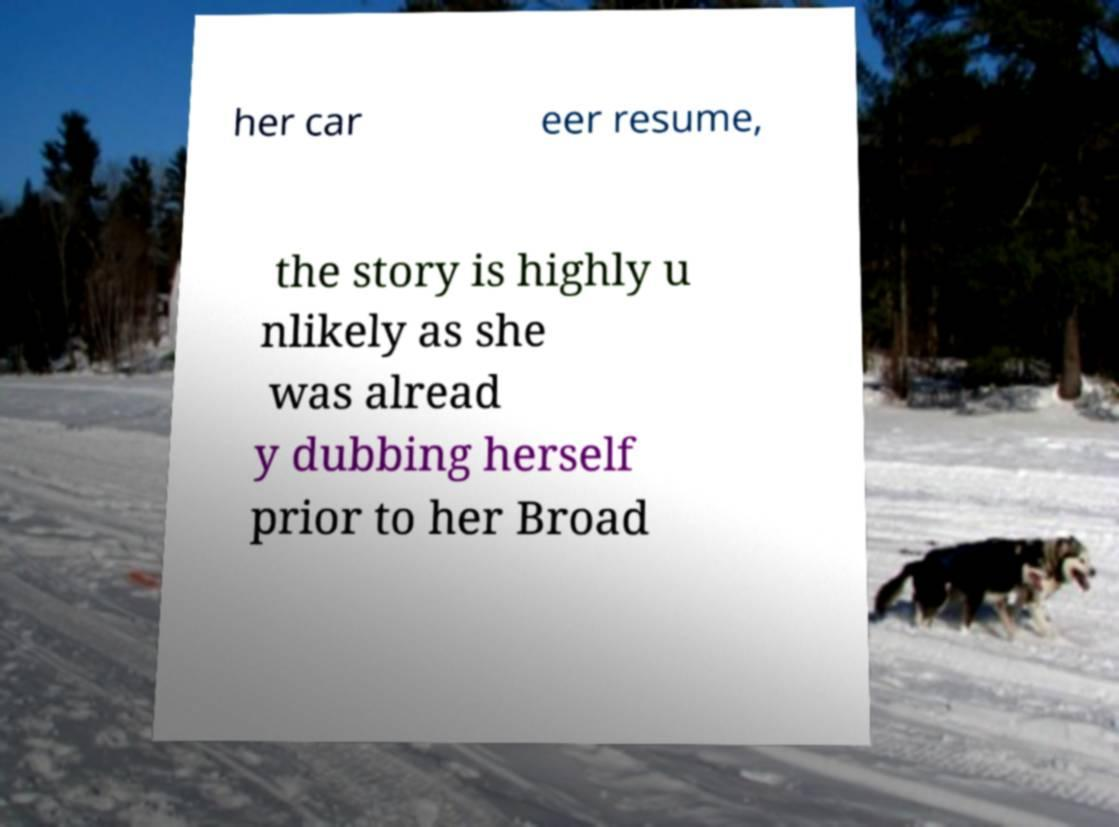Please read and relay the text visible in this image. What does it say? her car eer resume, the story is highly u nlikely as she was alread y dubbing herself prior to her Broad 